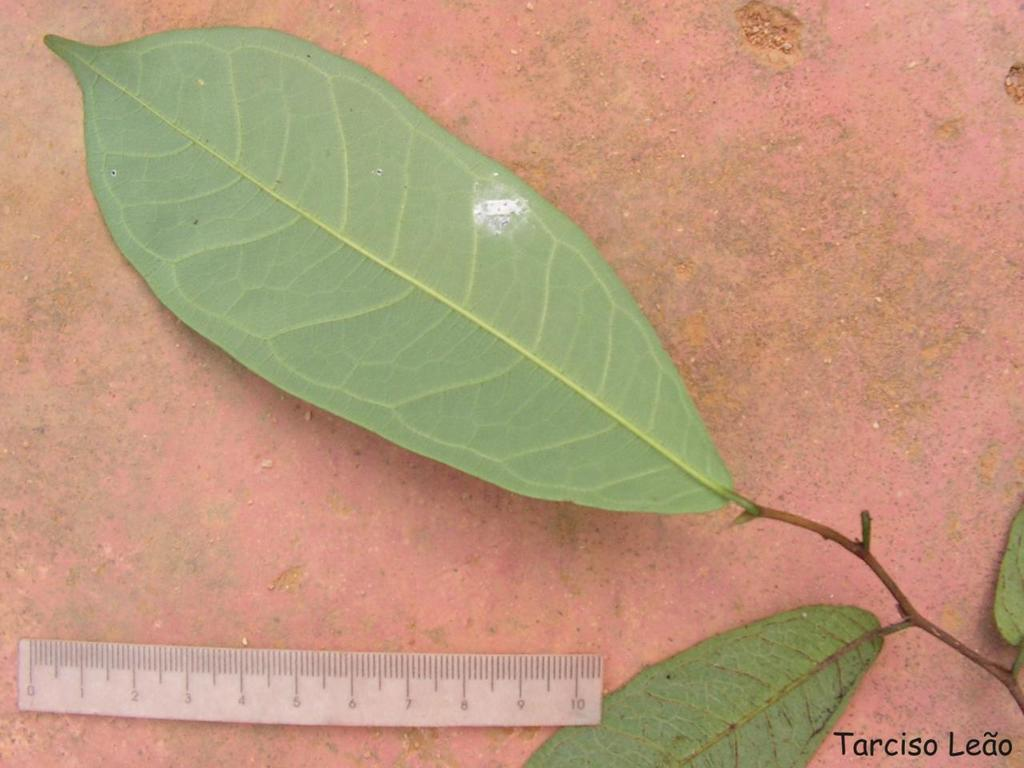<image>
Describe the image concisely. a green leaf that has the word Tarciso in the bottom right 